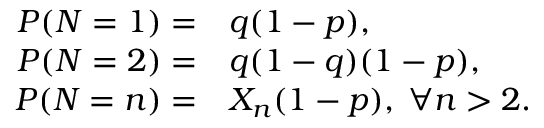Convert formula to latex. <formula><loc_0><loc_0><loc_500><loc_500>\begin{array} { r l } { P ( N = 1 ) = } & q ( 1 - p ) , } \\ { P ( N = 2 ) = } & q ( 1 - q ) ( 1 - p ) , } \\ { P ( N = n ) = } & X _ { n } ( 1 - p ) , \, \forall n > 2 . } \end{array}</formula> 